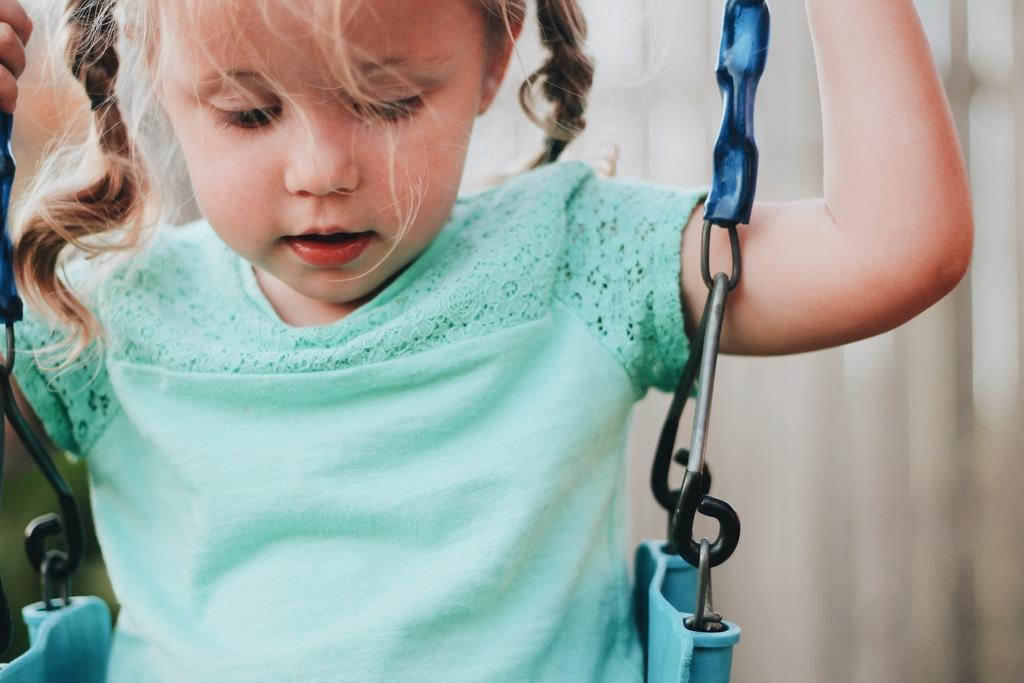Who is the main subject in the image? There is a girl in the image. What is the girl doing in the image? The girl is sitting on a swing. What actor is performing in the alley behind the girl in the image? There is no actor or alley present in the image; it only features a girl sitting on a swing. 